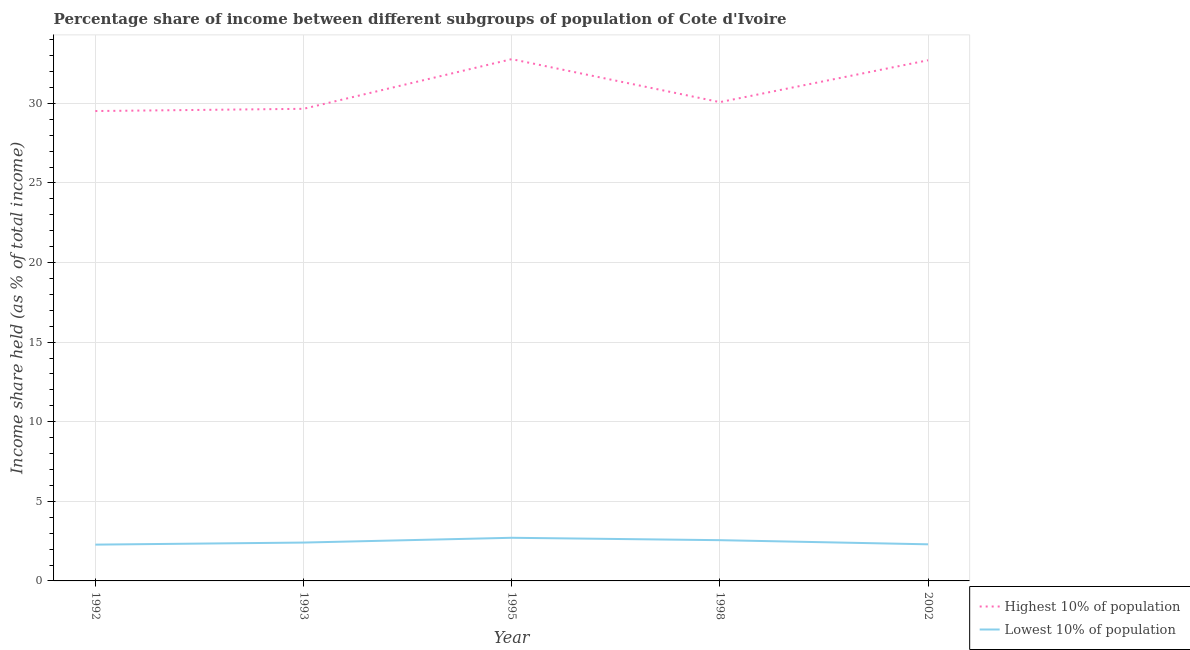What is the income share held by highest 10% of the population in 2002?
Make the answer very short. 32.71. Across all years, what is the maximum income share held by lowest 10% of the population?
Your answer should be very brief. 2.71. Across all years, what is the minimum income share held by lowest 10% of the population?
Ensure brevity in your answer.  2.28. In which year was the income share held by lowest 10% of the population maximum?
Your response must be concise. 1995. In which year was the income share held by highest 10% of the population minimum?
Your answer should be very brief. 1992. What is the total income share held by lowest 10% of the population in the graph?
Make the answer very short. 12.26. What is the difference between the income share held by highest 10% of the population in 1993 and that in 2002?
Ensure brevity in your answer.  -3.05. What is the difference between the income share held by highest 10% of the population in 1998 and the income share held by lowest 10% of the population in 2002?
Provide a short and direct response. 27.78. What is the average income share held by lowest 10% of the population per year?
Provide a succinct answer. 2.45. In the year 1995, what is the difference between the income share held by highest 10% of the population and income share held by lowest 10% of the population?
Offer a very short reply. 30.07. What is the ratio of the income share held by lowest 10% of the population in 1995 to that in 2002?
Provide a succinct answer. 1.18. Is the income share held by highest 10% of the population in 1992 less than that in 2002?
Your answer should be very brief. Yes. What is the difference between the highest and the second highest income share held by lowest 10% of the population?
Offer a very short reply. 0.15. What is the difference between the highest and the lowest income share held by highest 10% of the population?
Provide a short and direct response. 3.26. In how many years, is the income share held by lowest 10% of the population greater than the average income share held by lowest 10% of the population taken over all years?
Give a very brief answer. 2. Is the sum of the income share held by highest 10% of the population in 1992 and 1998 greater than the maximum income share held by lowest 10% of the population across all years?
Give a very brief answer. Yes. Is the income share held by highest 10% of the population strictly greater than the income share held by lowest 10% of the population over the years?
Provide a succinct answer. Yes. How many lines are there?
Your answer should be very brief. 2. How many years are there in the graph?
Your answer should be very brief. 5. Does the graph contain any zero values?
Your answer should be compact. No. Does the graph contain grids?
Provide a short and direct response. Yes. Where does the legend appear in the graph?
Ensure brevity in your answer.  Bottom right. How are the legend labels stacked?
Offer a terse response. Vertical. What is the title of the graph?
Ensure brevity in your answer.  Percentage share of income between different subgroups of population of Cote d'Ivoire. What is the label or title of the X-axis?
Your response must be concise. Year. What is the label or title of the Y-axis?
Provide a succinct answer. Income share held (as % of total income). What is the Income share held (as % of total income) in Highest 10% of population in 1992?
Ensure brevity in your answer.  29.52. What is the Income share held (as % of total income) in Lowest 10% of population in 1992?
Provide a succinct answer. 2.28. What is the Income share held (as % of total income) in Highest 10% of population in 1993?
Your answer should be very brief. 29.66. What is the Income share held (as % of total income) of Lowest 10% of population in 1993?
Your answer should be compact. 2.41. What is the Income share held (as % of total income) of Highest 10% of population in 1995?
Your answer should be very brief. 32.78. What is the Income share held (as % of total income) of Lowest 10% of population in 1995?
Ensure brevity in your answer.  2.71. What is the Income share held (as % of total income) of Highest 10% of population in 1998?
Your answer should be very brief. 30.08. What is the Income share held (as % of total income) in Lowest 10% of population in 1998?
Offer a very short reply. 2.56. What is the Income share held (as % of total income) of Highest 10% of population in 2002?
Keep it short and to the point. 32.71. Across all years, what is the maximum Income share held (as % of total income) in Highest 10% of population?
Keep it short and to the point. 32.78. Across all years, what is the maximum Income share held (as % of total income) of Lowest 10% of population?
Your answer should be compact. 2.71. Across all years, what is the minimum Income share held (as % of total income) in Highest 10% of population?
Make the answer very short. 29.52. Across all years, what is the minimum Income share held (as % of total income) in Lowest 10% of population?
Your response must be concise. 2.28. What is the total Income share held (as % of total income) in Highest 10% of population in the graph?
Your answer should be compact. 154.75. What is the total Income share held (as % of total income) of Lowest 10% of population in the graph?
Provide a short and direct response. 12.26. What is the difference between the Income share held (as % of total income) of Highest 10% of population in 1992 and that in 1993?
Your answer should be very brief. -0.14. What is the difference between the Income share held (as % of total income) of Lowest 10% of population in 1992 and that in 1993?
Offer a very short reply. -0.13. What is the difference between the Income share held (as % of total income) of Highest 10% of population in 1992 and that in 1995?
Provide a short and direct response. -3.26. What is the difference between the Income share held (as % of total income) of Lowest 10% of population in 1992 and that in 1995?
Keep it short and to the point. -0.43. What is the difference between the Income share held (as % of total income) of Highest 10% of population in 1992 and that in 1998?
Keep it short and to the point. -0.56. What is the difference between the Income share held (as % of total income) in Lowest 10% of population in 1992 and that in 1998?
Provide a succinct answer. -0.28. What is the difference between the Income share held (as % of total income) of Highest 10% of population in 1992 and that in 2002?
Give a very brief answer. -3.19. What is the difference between the Income share held (as % of total income) of Lowest 10% of population in 1992 and that in 2002?
Offer a terse response. -0.02. What is the difference between the Income share held (as % of total income) in Highest 10% of population in 1993 and that in 1995?
Your answer should be compact. -3.12. What is the difference between the Income share held (as % of total income) of Lowest 10% of population in 1993 and that in 1995?
Make the answer very short. -0.3. What is the difference between the Income share held (as % of total income) in Highest 10% of population in 1993 and that in 1998?
Ensure brevity in your answer.  -0.42. What is the difference between the Income share held (as % of total income) in Lowest 10% of population in 1993 and that in 1998?
Offer a terse response. -0.15. What is the difference between the Income share held (as % of total income) in Highest 10% of population in 1993 and that in 2002?
Your answer should be compact. -3.05. What is the difference between the Income share held (as % of total income) of Lowest 10% of population in 1993 and that in 2002?
Your answer should be very brief. 0.11. What is the difference between the Income share held (as % of total income) in Highest 10% of population in 1995 and that in 2002?
Provide a short and direct response. 0.07. What is the difference between the Income share held (as % of total income) in Lowest 10% of population in 1995 and that in 2002?
Make the answer very short. 0.41. What is the difference between the Income share held (as % of total income) of Highest 10% of population in 1998 and that in 2002?
Your answer should be very brief. -2.63. What is the difference between the Income share held (as % of total income) of Lowest 10% of population in 1998 and that in 2002?
Your answer should be very brief. 0.26. What is the difference between the Income share held (as % of total income) of Highest 10% of population in 1992 and the Income share held (as % of total income) of Lowest 10% of population in 1993?
Provide a succinct answer. 27.11. What is the difference between the Income share held (as % of total income) of Highest 10% of population in 1992 and the Income share held (as % of total income) of Lowest 10% of population in 1995?
Ensure brevity in your answer.  26.81. What is the difference between the Income share held (as % of total income) in Highest 10% of population in 1992 and the Income share held (as % of total income) in Lowest 10% of population in 1998?
Offer a terse response. 26.96. What is the difference between the Income share held (as % of total income) in Highest 10% of population in 1992 and the Income share held (as % of total income) in Lowest 10% of population in 2002?
Your answer should be compact. 27.22. What is the difference between the Income share held (as % of total income) in Highest 10% of population in 1993 and the Income share held (as % of total income) in Lowest 10% of population in 1995?
Offer a terse response. 26.95. What is the difference between the Income share held (as % of total income) in Highest 10% of population in 1993 and the Income share held (as % of total income) in Lowest 10% of population in 1998?
Offer a very short reply. 27.1. What is the difference between the Income share held (as % of total income) of Highest 10% of population in 1993 and the Income share held (as % of total income) of Lowest 10% of population in 2002?
Offer a terse response. 27.36. What is the difference between the Income share held (as % of total income) in Highest 10% of population in 1995 and the Income share held (as % of total income) in Lowest 10% of population in 1998?
Offer a terse response. 30.22. What is the difference between the Income share held (as % of total income) of Highest 10% of population in 1995 and the Income share held (as % of total income) of Lowest 10% of population in 2002?
Offer a very short reply. 30.48. What is the difference between the Income share held (as % of total income) of Highest 10% of population in 1998 and the Income share held (as % of total income) of Lowest 10% of population in 2002?
Your answer should be compact. 27.78. What is the average Income share held (as % of total income) in Highest 10% of population per year?
Provide a short and direct response. 30.95. What is the average Income share held (as % of total income) of Lowest 10% of population per year?
Give a very brief answer. 2.45. In the year 1992, what is the difference between the Income share held (as % of total income) of Highest 10% of population and Income share held (as % of total income) of Lowest 10% of population?
Your answer should be very brief. 27.24. In the year 1993, what is the difference between the Income share held (as % of total income) of Highest 10% of population and Income share held (as % of total income) of Lowest 10% of population?
Make the answer very short. 27.25. In the year 1995, what is the difference between the Income share held (as % of total income) of Highest 10% of population and Income share held (as % of total income) of Lowest 10% of population?
Offer a very short reply. 30.07. In the year 1998, what is the difference between the Income share held (as % of total income) of Highest 10% of population and Income share held (as % of total income) of Lowest 10% of population?
Your answer should be very brief. 27.52. In the year 2002, what is the difference between the Income share held (as % of total income) in Highest 10% of population and Income share held (as % of total income) in Lowest 10% of population?
Ensure brevity in your answer.  30.41. What is the ratio of the Income share held (as % of total income) of Lowest 10% of population in 1992 to that in 1993?
Offer a terse response. 0.95. What is the ratio of the Income share held (as % of total income) of Highest 10% of population in 1992 to that in 1995?
Your answer should be compact. 0.9. What is the ratio of the Income share held (as % of total income) in Lowest 10% of population in 1992 to that in 1995?
Provide a succinct answer. 0.84. What is the ratio of the Income share held (as % of total income) in Highest 10% of population in 1992 to that in 1998?
Provide a succinct answer. 0.98. What is the ratio of the Income share held (as % of total income) of Lowest 10% of population in 1992 to that in 1998?
Your response must be concise. 0.89. What is the ratio of the Income share held (as % of total income) in Highest 10% of population in 1992 to that in 2002?
Ensure brevity in your answer.  0.9. What is the ratio of the Income share held (as % of total income) of Lowest 10% of population in 1992 to that in 2002?
Offer a terse response. 0.99. What is the ratio of the Income share held (as % of total income) in Highest 10% of population in 1993 to that in 1995?
Provide a succinct answer. 0.9. What is the ratio of the Income share held (as % of total income) in Lowest 10% of population in 1993 to that in 1995?
Provide a short and direct response. 0.89. What is the ratio of the Income share held (as % of total income) of Highest 10% of population in 1993 to that in 1998?
Offer a very short reply. 0.99. What is the ratio of the Income share held (as % of total income) in Lowest 10% of population in 1993 to that in 1998?
Your answer should be compact. 0.94. What is the ratio of the Income share held (as % of total income) in Highest 10% of population in 1993 to that in 2002?
Provide a short and direct response. 0.91. What is the ratio of the Income share held (as % of total income) of Lowest 10% of population in 1993 to that in 2002?
Make the answer very short. 1.05. What is the ratio of the Income share held (as % of total income) of Highest 10% of population in 1995 to that in 1998?
Ensure brevity in your answer.  1.09. What is the ratio of the Income share held (as % of total income) of Lowest 10% of population in 1995 to that in 1998?
Provide a short and direct response. 1.06. What is the ratio of the Income share held (as % of total income) of Highest 10% of population in 1995 to that in 2002?
Your answer should be compact. 1. What is the ratio of the Income share held (as % of total income) of Lowest 10% of population in 1995 to that in 2002?
Keep it short and to the point. 1.18. What is the ratio of the Income share held (as % of total income) of Highest 10% of population in 1998 to that in 2002?
Make the answer very short. 0.92. What is the ratio of the Income share held (as % of total income) of Lowest 10% of population in 1998 to that in 2002?
Your answer should be very brief. 1.11. What is the difference between the highest and the second highest Income share held (as % of total income) in Highest 10% of population?
Your answer should be very brief. 0.07. What is the difference between the highest and the lowest Income share held (as % of total income) in Highest 10% of population?
Your answer should be compact. 3.26. What is the difference between the highest and the lowest Income share held (as % of total income) of Lowest 10% of population?
Keep it short and to the point. 0.43. 